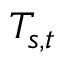Convert formula to latex. <formula><loc_0><loc_0><loc_500><loc_500>T _ { s , t }</formula> 